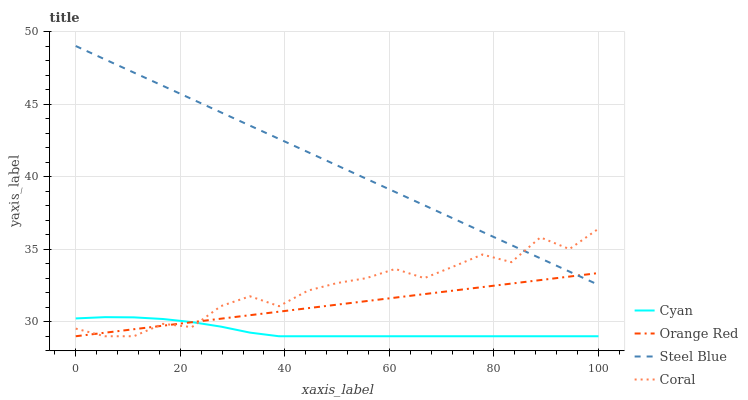Does Cyan have the minimum area under the curve?
Answer yes or no. Yes. Does Steel Blue have the maximum area under the curve?
Answer yes or no. Yes. Does Coral have the minimum area under the curve?
Answer yes or no. No. Does Coral have the maximum area under the curve?
Answer yes or no. No. Is Steel Blue the smoothest?
Answer yes or no. Yes. Is Coral the roughest?
Answer yes or no. Yes. Is Orange Red the smoothest?
Answer yes or no. No. Is Orange Red the roughest?
Answer yes or no. No. Does Cyan have the lowest value?
Answer yes or no. Yes. Does Steel Blue have the lowest value?
Answer yes or no. No. Does Steel Blue have the highest value?
Answer yes or no. Yes. Does Coral have the highest value?
Answer yes or no. No. Is Cyan less than Steel Blue?
Answer yes or no. Yes. Is Steel Blue greater than Cyan?
Answer yes or no. Yes. Does Orange Red intersect Coral?
Answer yes or no. Yes. Is Orange Red less than Coral?
Answer yes or no. No. Is Orange Red greater than Coral?
Answer yes or no. No. Does Cyan intersect Steel Blue?
Answer yes or no. No. 